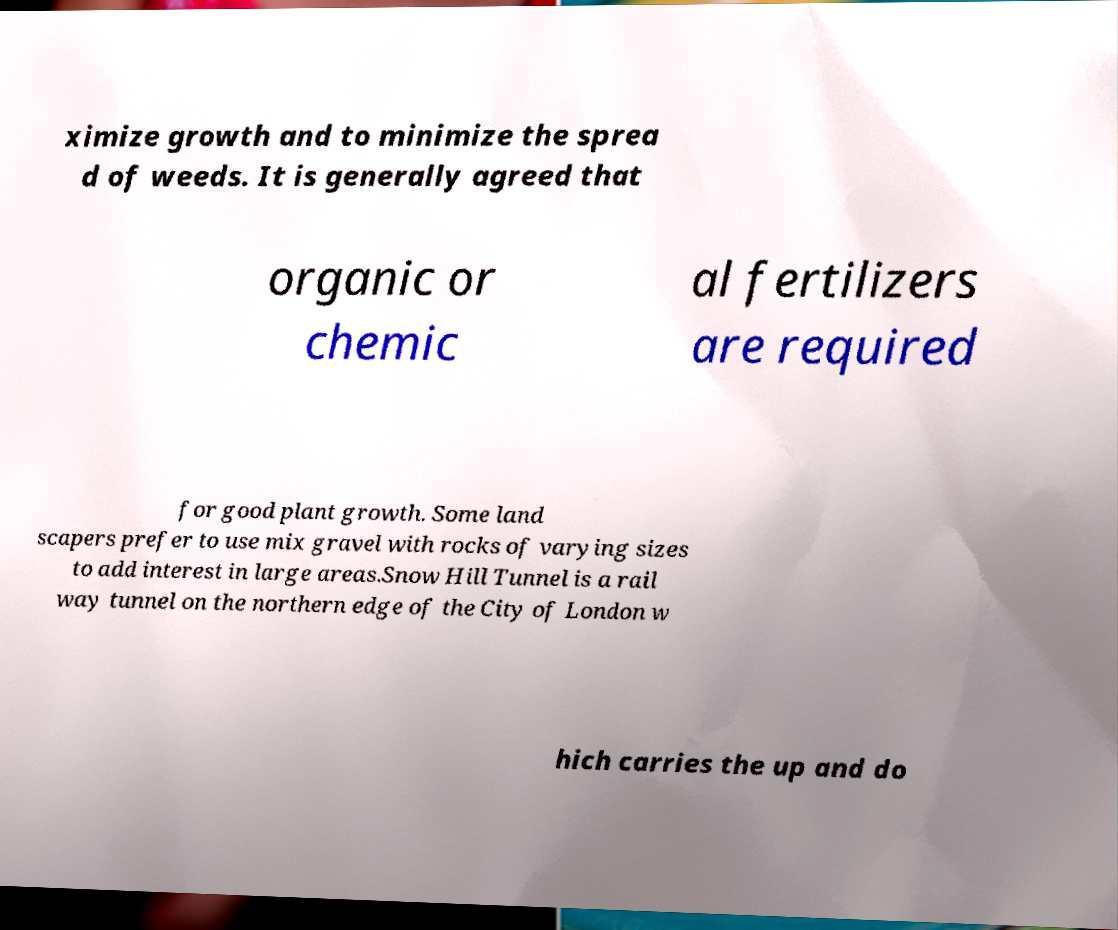Please read and relay the text visible in this image. What does it say? ximize growth and to minimize the sprea d of weeds. It is generally agreed that organic or chemic al fertilizers are required for good plant growth. Some land scapers prefer to use mix gravel with rocks of varying sizes to add interest in large areas.Snow Hill Tunnel is a rail way tunnel on the northern edge of the City of London w hich carries the up and do 